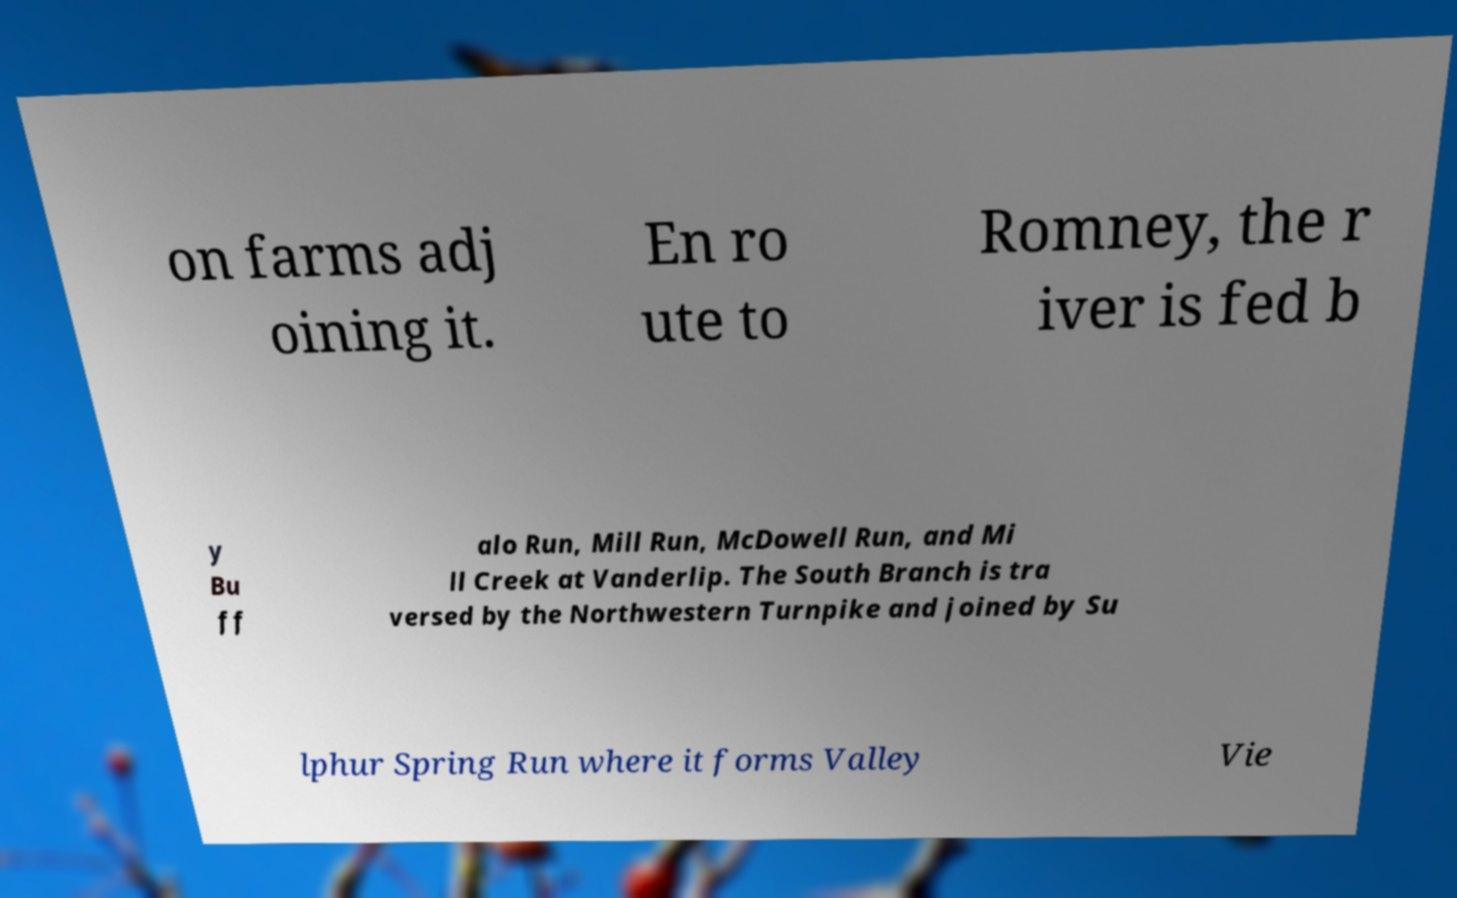Can you accurately transcribe the text from the provided image for me? on farms adj oining it. En ro ute to Romney, the r iver is fed b y Bu ff alo Run, Mill Run, McDowell Run, and Mi ll Creek at Vanderlip. The South Branch is tra versed by the Northwestern Turnpike and joined by Su lphur Spring Run where it forms Valley Vie 